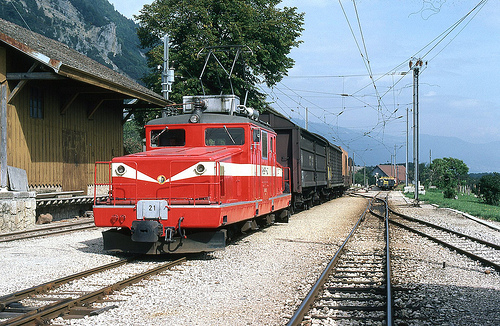Describe the environment depicted around the railway track. The environment around the railway track is lush and green, with mountains in the background, suggesting a rural or possibly mountainous area conducive to scenic rail routes. Are there any significant geographical features visible? Yes, the large, forested mountains in the distance are significant geographical features, adding to the beauty and possibly influencing the area's climate. 